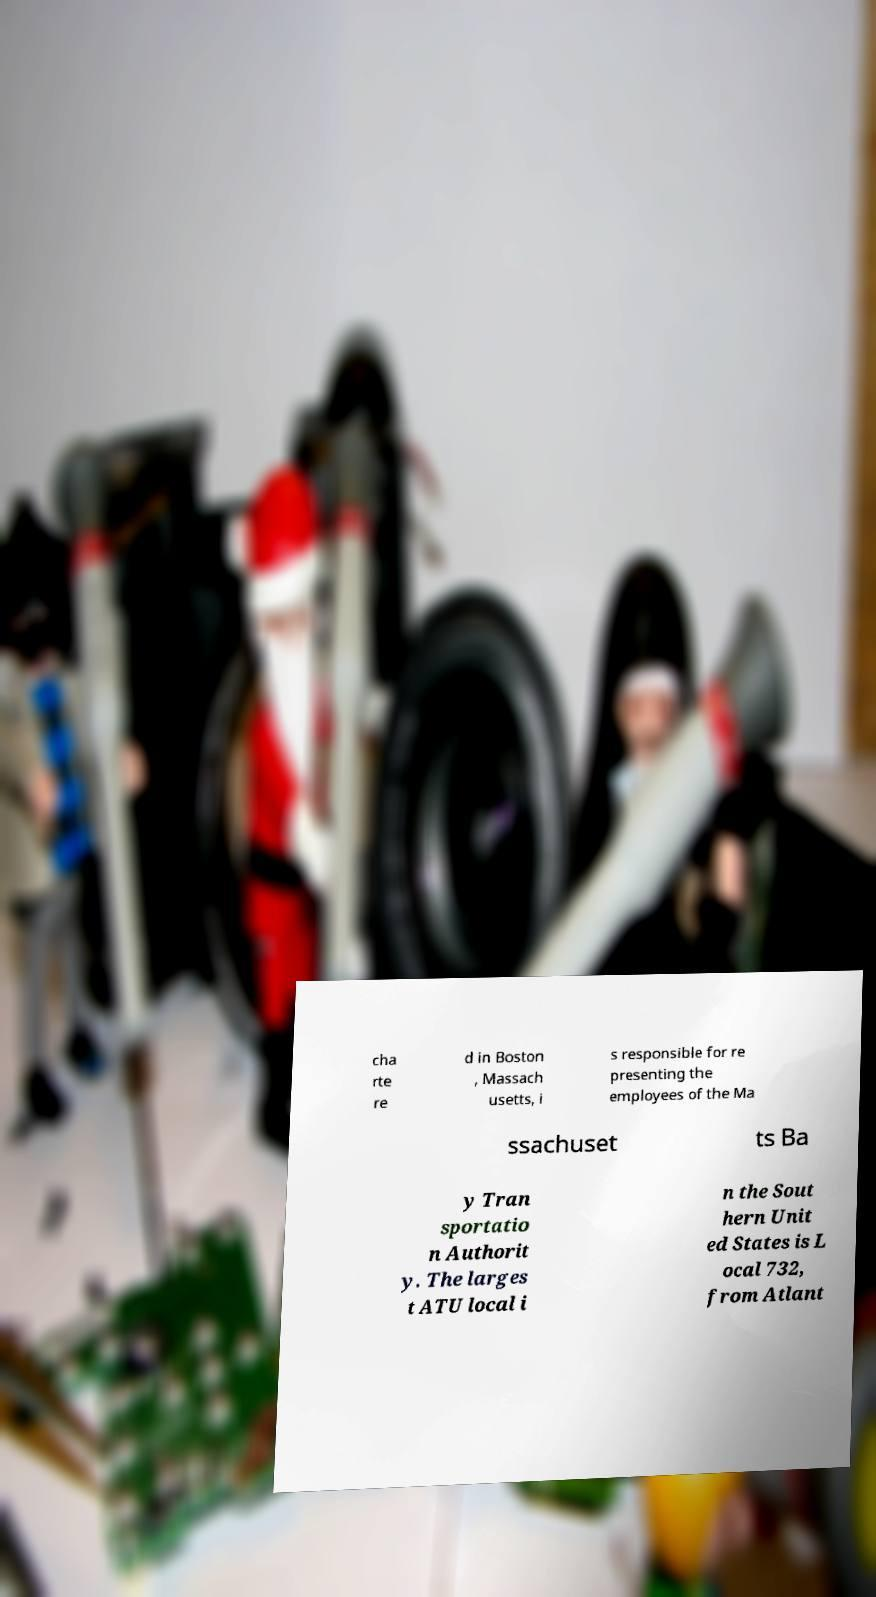For documentation purposes, I need the text within this image transcribed. Could you provide that? cha rte re d in Boston , Massach usetts, i s responsible for re presenting the employees of the Ma ssachuset ts Ba y Tran sportatio n Authorit y. The larges t ATU local i n the Sout hern Unit ed States is L ocal 732, from Atlant 